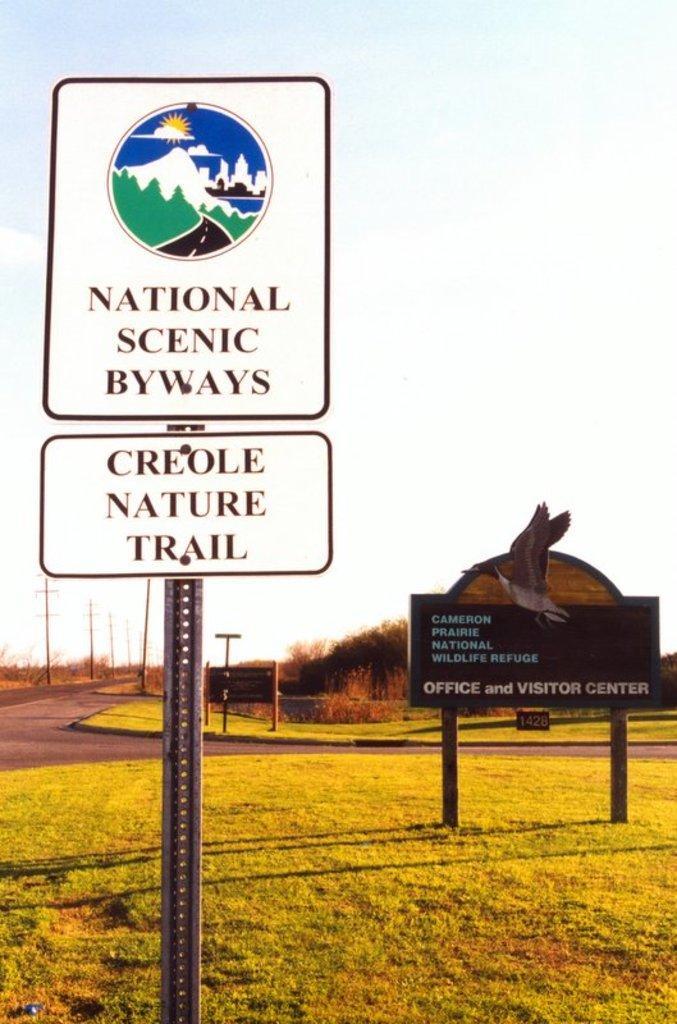How would you summarize this image in a sentence or two? In the image there is a metal pole, there are two boards attached to that pole with some text and behind that there is a board dug into the ground which is containing a lot of grass, behind that ground there is an empty road and in the background there are some trees. 